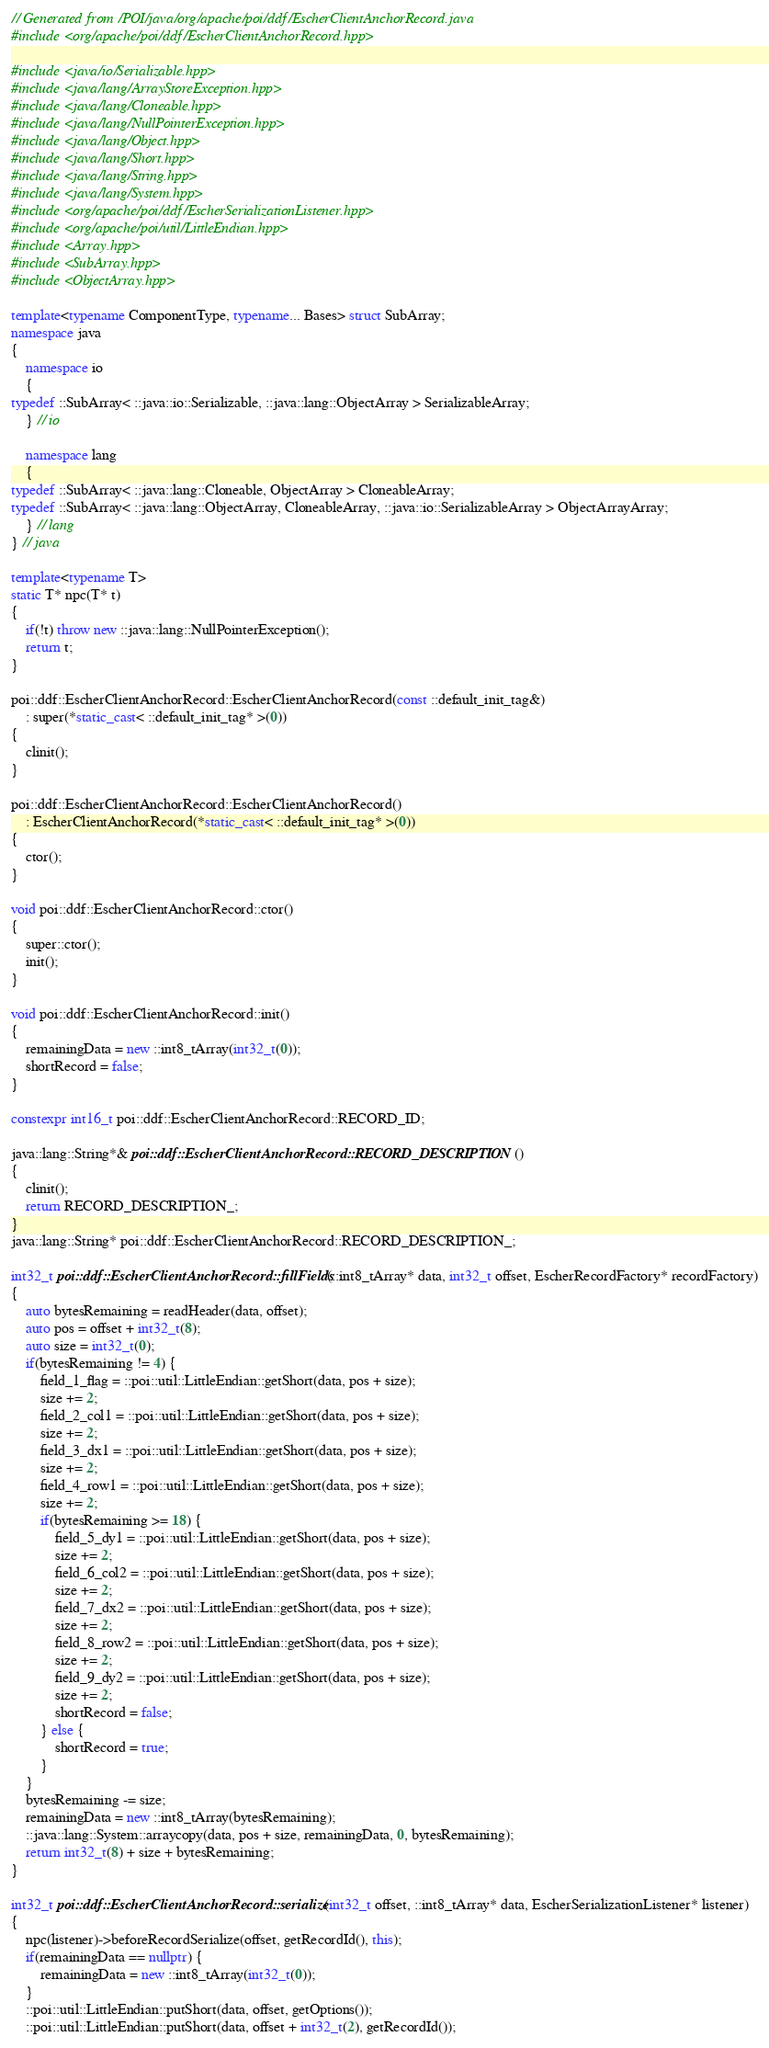<code> <loc_0><loc_0><loc_500><loc_500><_C++_>// Generated from /POI/java/org/apache/poi/ddf/EscherClientAnchorRecord.java
#include <org/apache/poi/ddf/EscherClientAnchorRecord.hpp>

#include <java/io/Serializable.hpp>
#include <java/lang/ArrayStoreException.hpp>
#include <java/lang/Cloneable.hpp>
#include <java/lang/NullPointerException.hpp>
#include <java/lang/Object.hpp>
#include <java/lang/Short.hpp>
#include <java/lang/String.hpp>
#include <java/lang/System.hpp>
#include <org/apache/poi/ddf/EscherSerializationListener.hpp>
#include <org/apache/poi/util/LittleEndian.hpp>
#include <Array.hpp>
#include <SubArray.hpp>
#include <ObjectArray.hpp>

template<typename ComponentType, typename... Bases> struct SubArray;
namespace java
{
    namespace io
    {
typedef ::SubArray< ::java::io::Serializable, ::java::lang::ObjectArray > SerializableArray;
    } // io

    namespace lang
    {
typedef ::SubArray< ::java::lang::Cloneable, ObjectArray > CloneableArray;
typedef ::SubArray< ::java::lang::ObjectArray, CloneableArray, ::java::io::SerializableArray > ObjectArrayArray;
    } // lang
} // java

template<typename T>
static T* npc(T* t)
{
    if(!t) throw new ::java::lang::NullPointerException();
    return t;
}

poi::ddf::EscherClientAnchorRecord::EscherClientAnchorRecord(const ::default_init_tag&)
    : super(*static_cast< ::default_init_tag* >(0))
{
    clinit();
}

poi::ddf::EscherClientAnchorRecord::EscherClientAnchorRecord()
    : EscherClientAnchorRecord(*static_cast< ::default_init_tag* >(0))
{
    ctor();
}

void poi::ddf::EscherClientAnchorRecord::ctor()
{
    super::ctor();
    init();
}

void poi::ddf::EscherClientAnchorRecord::init()
{
    remainingData = new ::int8_tArray(int32_t(0));
    shortRecord = false;
}

constexpr int16_t poi::ddf::EscherClientAnchorRecord::RECORD_ID;

java::lang::String*& poi::ddf::EscherClientAnchorRecord::RECORD_DESCRIPTION()
{
    clinit();
    return RECORD_DESCRIPTION_;
}
java::lang::String* poi::ddf::EscherClientAnchorRecord::RECORD_DESCRIPTION_;

int32_t poi::ddf::EscherClientAnchorRecord::fillFields(::int8_tArray* data, int32_t offset, EscherRecordFactory* recordFactory)
{
    auto bytesRemaining = readHeader(data, offset);
    auto pos = offset + int32_t(8);
    auto size = int32_t(0);
    if(bytesRemaining != 4) {
        field_1_flag = ::poi::util::LittleEndian::getShort(data, pos + size);
        size += 2;
        field_2_col1 = ::poi::util::LittleEndian::getShort(data, pos + size);
        size += 2;
        field_3_dx1 = ::poi::util::LittleEndian::getShort(data, pos + size);
        size += 2;
        field_4_row1 = ::poi::util::LittleEndian::getShort(data, pos + size);
        size += 2;
        if(bytesRemaining >= 18) {
            field_5_dy1 = ::poi::util::LittleEndian::getShort(data, pos + size);
            size += 2;
            field_6_col2 = ::poi::util::LittleEndian::getShort(data, pos + size);
            size += 2;
            field_7_dx2 = ::poi::util::LittleEndian::getShort(data, pos + size);
            size += 2;
            field_8_row2 = ::poi::util::LittleEndian::getShort(data, pos + size);
            size += 2;
            field_9_dy2 = ::poi::util::LittleEndian::getShort(data, pos + size);
            size += 2;
            shortRecord = false;
        } else {
            shortRecord = true;
        }
    }
    bytesRemaining -= size;
    remainingData = new ::int8_tArray(bytesRemaining);
    ::java::lang::System::arraycopy(data, pos + size, remainingData, 0, bytesRemaining);
    return int32_t(8) + size + bytesRemaining;
}

int32_t poi::ddf::EscherClientAnchorRecord::serialize(int32_t offset, ::int8_tArray* data, EscherSerializationListener* listener)
{
    npc(listener)->beforeRecordSerialize(offset, getRecordId(), this);
    if(remainingData == nullptr) {
        remainingData = new ::int8_tArray(int32_t(0));
    }
    ::poi::util::LittleEndian::putShort(data, offset, getOptions());
    ::poi::util::LittleEndian::putShort(data, offset + int32_t(2), getRecordId());</code> 